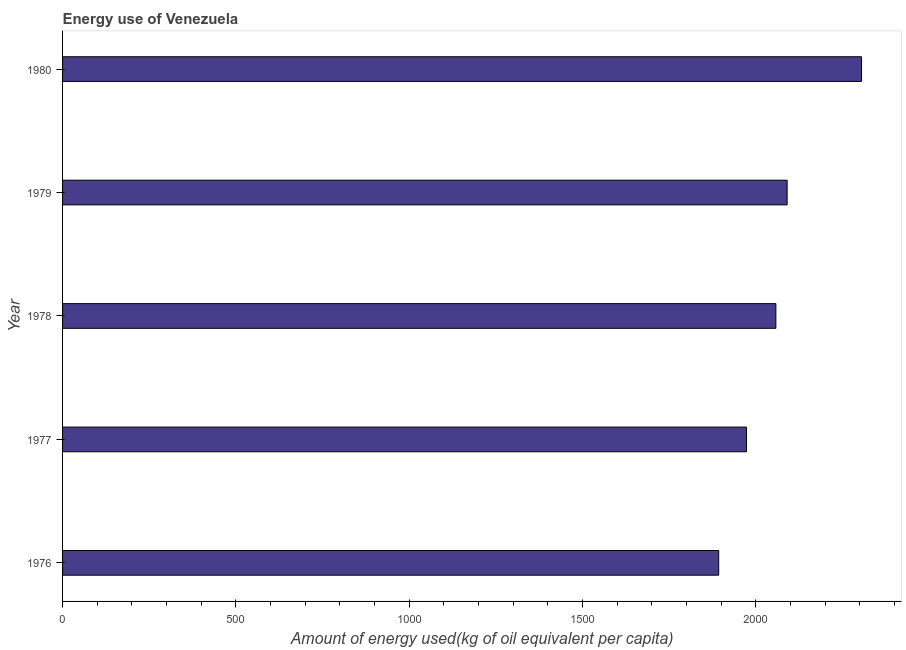Does the graph contain any zero values?
Offer a very short reply. No. What is the title of the graph?
Offer a terse response. Energy use of Venezuela. What is the label or title of the X-axis?
Your answer should be very brief. Amount of energy used(kg of oil equivalent per capita). What is the amount of energy used in 1976?
Ensure brevity in your answer.  1892.5. Across all years, what is the maximum amount of energy used?
Your response must be concise. 2304.51. Across all years, what is the minimum amount of energy used?
Provide a short and direct response. 1892.5. In which year was the amount of energy used maximum?
Your answer should be compact. 1980. In which year was the amount of energy used minimum?
Offer a terse response. 1976. What is the sum of the amount of energy used?
Offer a very short reply. 1.03e+04. What is the difference between the amount of energy used in 1978 and 1979?
Give a very brief answer. -32.46. What is the average amount of energy used per year?
Offer a very short reply. 2063.4. What is the median amount of energy used?
Provide a short and direct response. 2057.42. In how many years, is the amount of energy used greater than 1700 kg?
Offer a terse response. 5. What is the ratio of the amount of energy used in 1977 to that in 1979?
Your answer should be compact. 0.94. What is the difference between the highest and the second highest amount of energy used?
Keep it short and to the point. 214.63. Is the sum of the amount of energy used in 1976 and 1978 greater than the maximum amount of energy used across all years?
Give a very brief answer. Yes. What is the difference between the highest and the lowest amount of energy used?
Your answer should be very brief. 412. What is the difference between two consecutive major ticks on the X-axis?
Make the answer very short. 500. Are the values on the major ticks of X-axis written in scientific E-notation?
Your answer should be compact. No. What is the Amount of energy used(kg of oil equivalent per capita) in 1976?
Offer a terse response. 1892.5. What is the Amount of energy used(kg of oil equivalent per capita) in 1977?
Your answer should be compact. 1972.69. What is the Amount of energy used(kg of oil equivalent per capita) in 1978?
Provide a short and direct response. 2057.42. What is the Amount of energy used(kg of oil equivalent per capita) in 1979?
Provide a succinct answer. 2089.88. What is the Amount of energy used(kg of oil equivalent per capita) in 1980?
Provide a short and direct response. 2304.51. What is the difference between the Amount of energy used(kg of oil equivalent per capita) in 1976 and 1977?
Offer a terse response. -80.19. What is the difference between the Amount of energy used(kg of oil equivalent per capita) in 1976 and 1978?
Keep it short and to the point. -164.91. What is the difference between the Amount of energy used(kg of oil equivalent per capita) in 1976 and 1979?
Keep it short and to the point. -197.37. What is the difference between the Amount of energy used(kg of oil equivalent per capita) in 1976 and 1980?
Offer a very short reply. -412. What is the difference between the Amount of energy used(kg of oil equivalent per capita) in 1977 and 1978?
Your answer should be compact. -84.73. What is the difference between the Amount of energy used(kg of oil equivalent per capita) in 1977 and 1979?
Your answer should be very brief. -117.19. What is the difference between the Amount of energy used(kg of oil equivalent per capita) in 1977 and 1980?
Your response must be concise. -331.82. What is the difference between the Amount of energy used(kg of oil equivalent per capita) in 1978 and 1979?
Provide a short and direct response. -32.46. What is the difference between the Amount of energy used(kg of oil equivalent per capita) in 1978 and 1980?
Your answer should be very brief. -247.09. What is the difference between the Amount of energy used(kg of oil equivalent per capita) in 1979 and 1980?
Your response must be concise. -214.63. What is the ratio of the Amount of energy used(kg of oil equivalent per capita) in 1976 to that in 1977?
Ensure brevity in your answer.  0.96. What is the ratio of the Amount of energy used(kg of oil equivalent per capita) in 1976 to that in 1979?
Provide a succinct answer. 0.91. What is the ratio of the Amount of energy used(kg of oil equivalent per capita) in 1976 to that in 1980?
Provide a succinct answer. 0.82. What is the ratio of the Amount of energy used(kg of oil equivalent per capita) in 1977 to that in 1979?
Offer a very short reply. 0.94. What is the ratio of the Amount of energy used(kg of oil equivalent per capita) in 1977 to that in 1980?
Your answer should be compact. 0.86. What is the ratio of the Amount of energy used(kg of oil equivalent per capita) in 1978 to that in 1980?
Make the answer very short. 0.89. What is the ratio of the Amount of energy used(kg of oil equivalent per capita) in 1979 to that in 1980?
Ensure brevity in your answer.  0.91. 